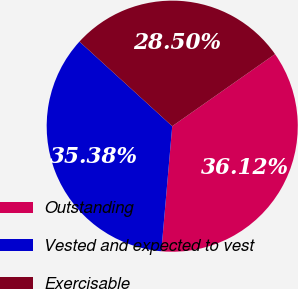Convert chart to OTSL. <chart><loc_0><loc_0><loc_500><loc_500><pie_chart><fcel>Outstanding<fcel>Vested and expected to vest<fcel>Exercisable<nl><fcel>36.12%<fcel>35.38%<fcel>28.5%<nl></chart> 